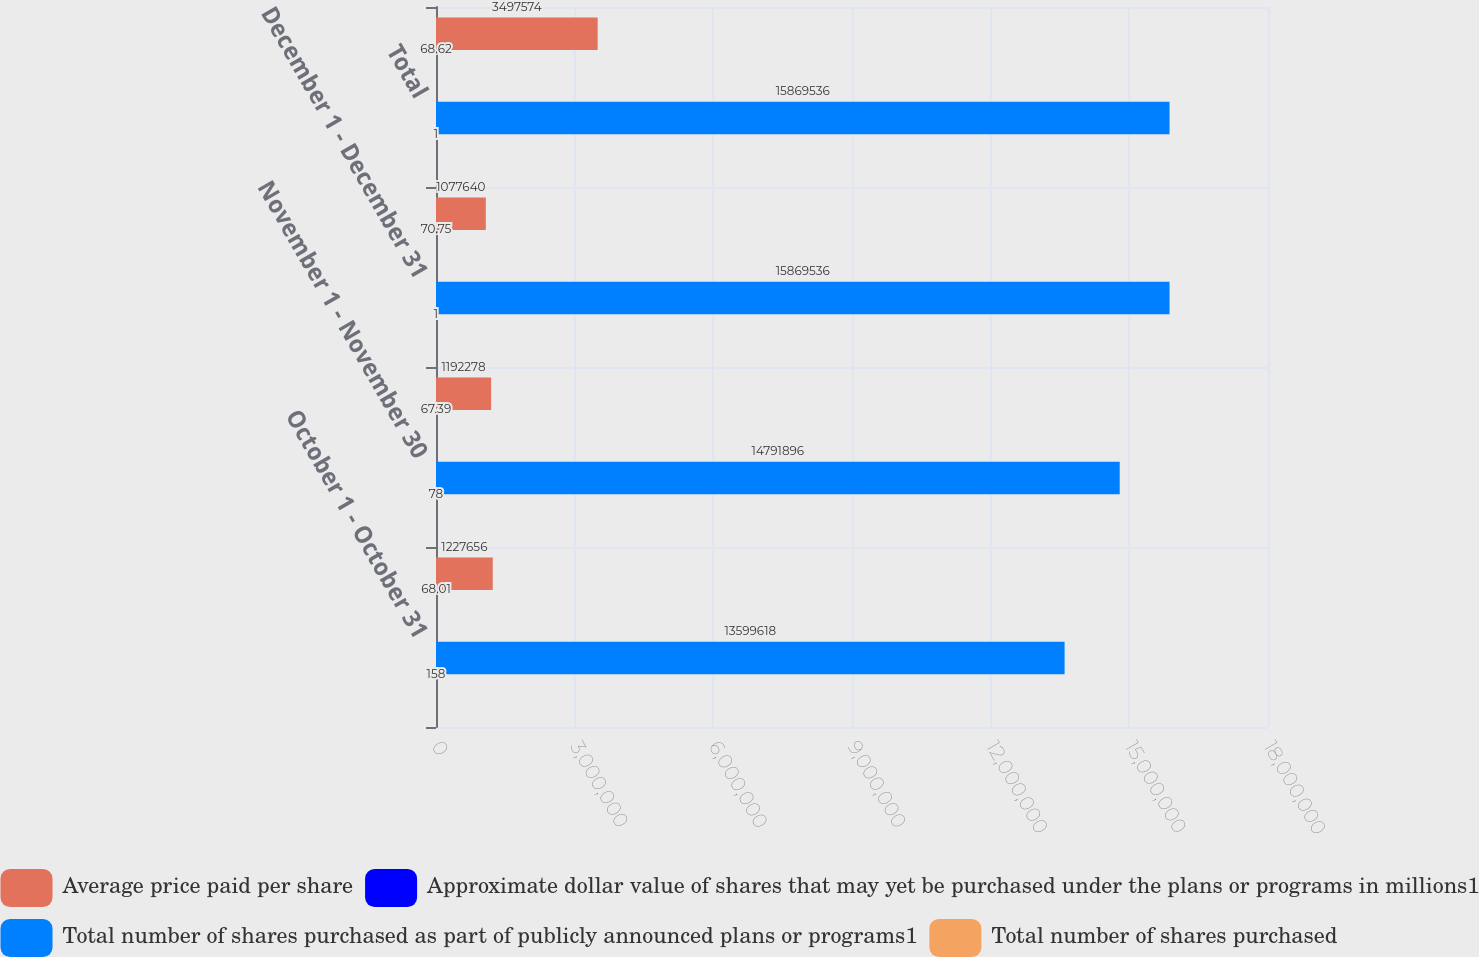Convert chart to OTSL. <chart><loc_0><loc_0><loc_500><loc_500><stacked_bar_chart><ecel><fcel>October 1 - October 31<fcel>November 1 - November 30<fcel>December 1 - December 31<fcel>Total<nl><fcel>Average price paid per share<fcel>1.22766e+06<fcel>1.19228e+06<fcel>1.07764e+06<fcel>3.49757e+06<nl><fcel>Approximate dollar value of shares that may yet be purchased under the plans or programs in millions1<fcel>68.01<fcel>67.39<fcel>70.75<fcel>68.62<nl><fcel>Total number of shares purchased as part of publicly announced plans or programs1<fcel>1.35996e+07<fcel>1.47919e+07<fcel>1.58695e+07<fcel>1.58695e+07<nl><fcel>Total number of shares purchased<fcel>158<fcel>78<fcel>1<fcel>1<nl></chart> 